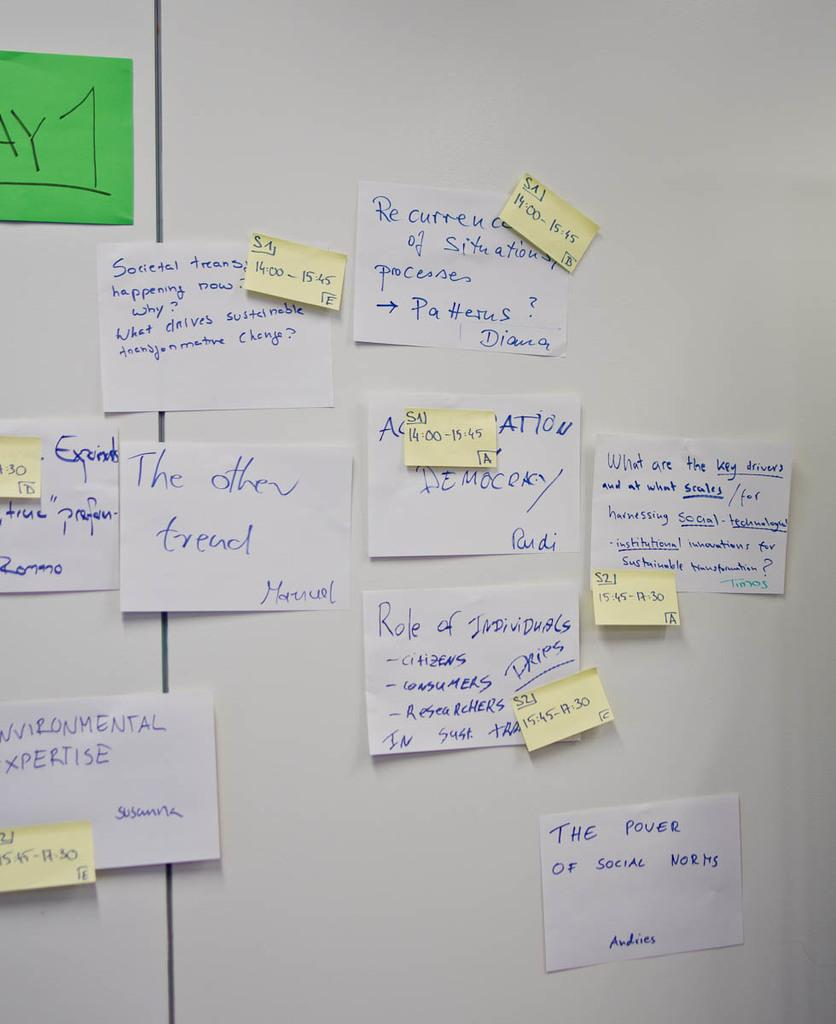Provide a one-sentence caption for the provided image. White background littered with "Day 1" sticky notes which seem to act as guidelines for workers. 